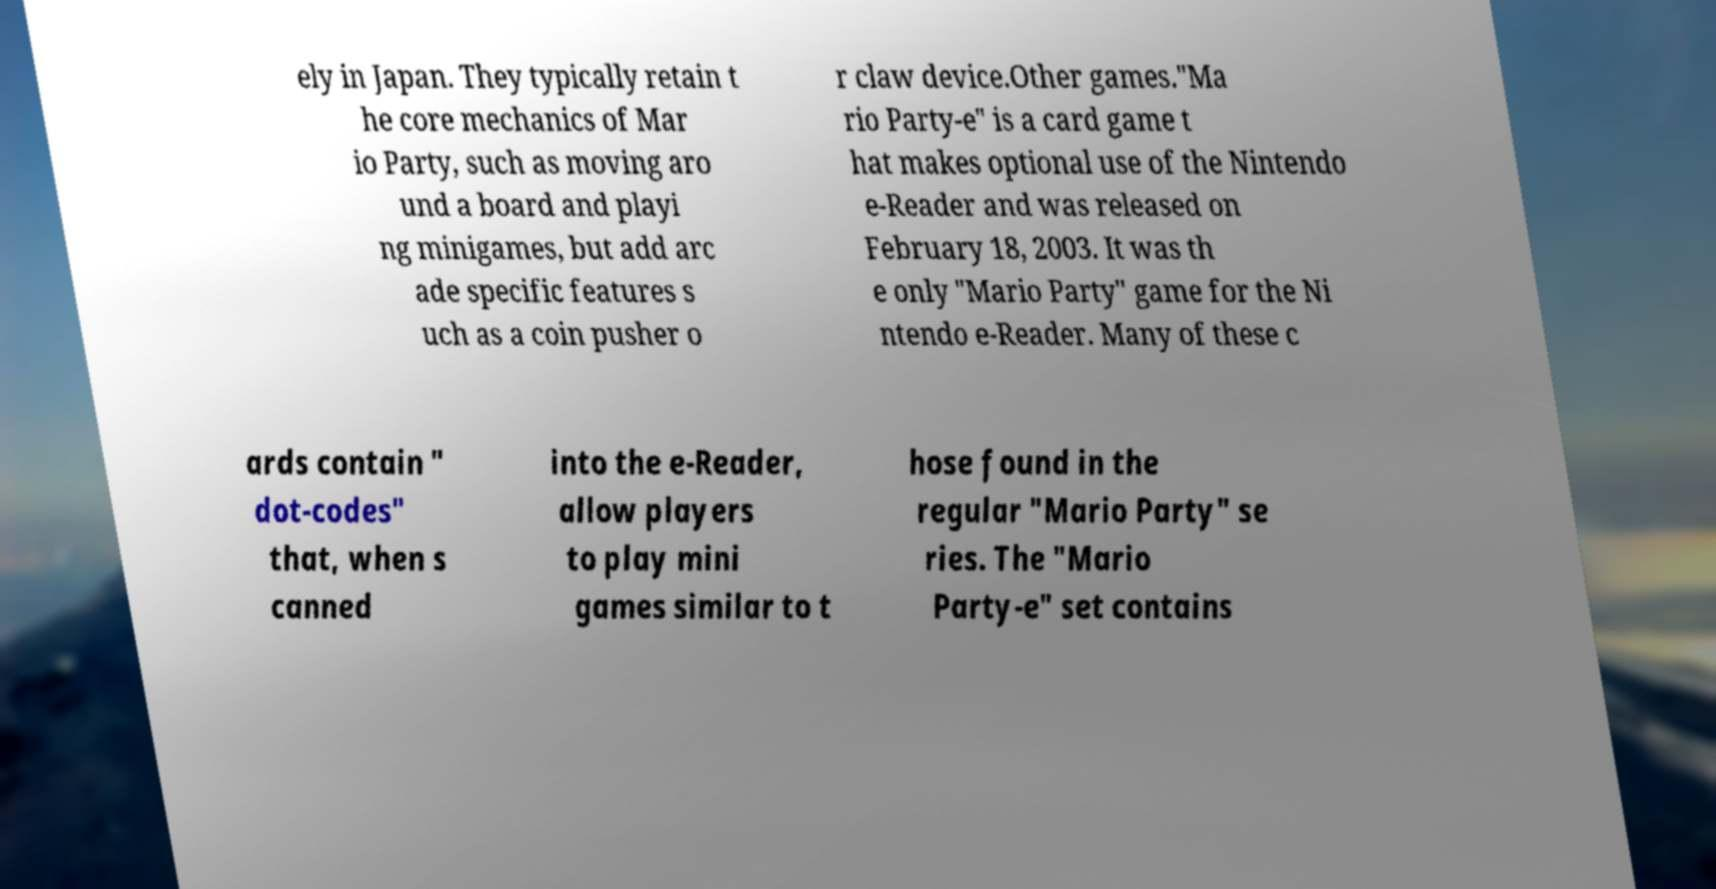Can you accurately transcribe the text from the provided image for me? ely in Japan. They typically retain t he core mechanics of Mar io Party, such as moving aro und a board and playi ng minigames, but add arc ade specific features s uch as a coin pusher o r claw device.Other games."Ma rio Party-e" is a card game t hat makes optional use of the Nintendo e-Reader and was released on February 18, 2003. It was th e only "Mario Party" game for the Ni ntendo e-Reader. Many of these c ards contain " dot-codes" that, when s canned into the e-Reader, allow players to play mini games similar to t hose found in the regular "Mario Party" se ries. The "Mario Party-e" set contains 